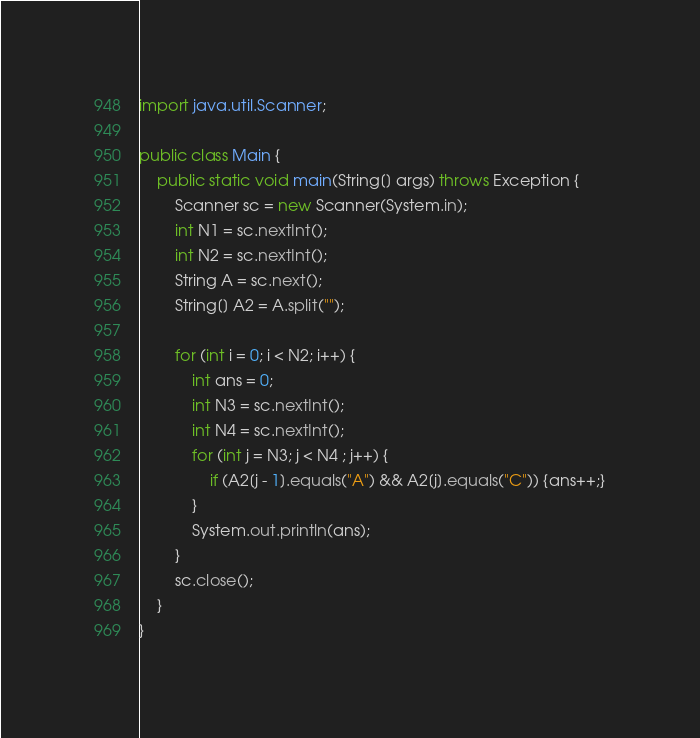Convert code to text. <code><loc_0><loc_0><loc_500><loc_500><_Java_>import java.util.Scanner;

public class Main {
	public static void main(String[] args) throws Exception {
		Scanner sc = new Scanner(System.in);
		int N1 = sc.nextInt();
		int N2 = sc.nextInt();
		String A = sc.next();
		String[] A2 = A.split("");

		for (int i = 0; i < N2; i++) {
			int ans = 0;
			int N3 = sc.nextInt();
			int N4 = sc.nextInt();
			for (int j = N3; j < N4 ; j++) {
				if (A2[j - 1].equals("A") && A2[j].equals("C")) {ans++;}
			}
			System.out.println(ans);
		}
		sc.close();
	}
}
</code> 